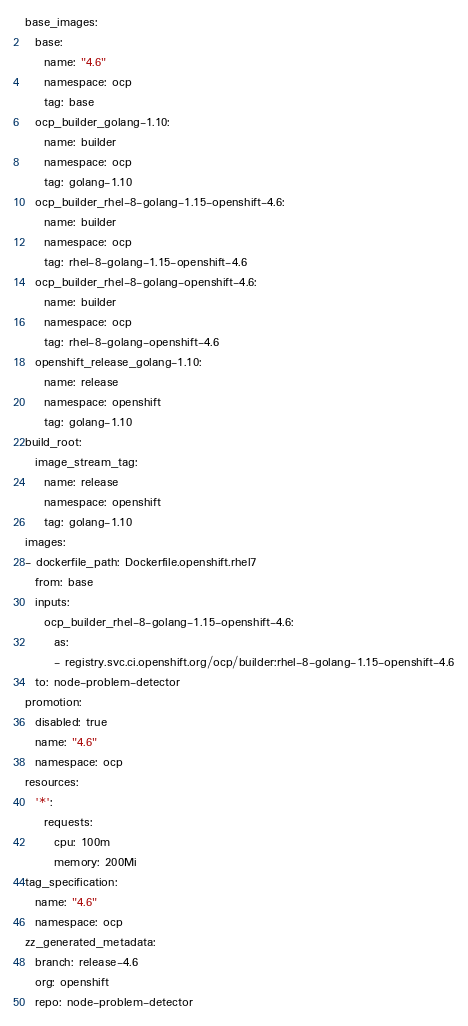<code> <loc_0><loc_0><loc_500><loc_500><_YAML_>base_images:
  base:
    name: "4.6"
    namespace: ocp
    tag: base
  ocp_builder_golang-1.10:
    name: builder
    namespace: ocp
    tag: golang-1.10
  ocp_builder_rhel-8-golang-1.15-openshift-4.6:
    name: builder
    namespace: ocp
    tag: rhel-8-golang-1.15-openshift-4.6
  ocp_builder_rhel-8-golang-openshift-4.6:
    name: builder
    namespace: ocp
    tag: rhel-8-golang-openshift-4.6
  openshift_release_golang-1.10:
    name: release
    namespace: openshift
    tag: golang-1.10
build_root:
  image_stream_tag:
    name: release
    namespace: openshift
    tag: golang-1.10
images:
- dockerfile_path: Dockerfile.openshift.rhel7
  from: base
  inputs:
    ocp_builder_rhel-8-golang-1.15-openshift-4.6:
      as:
      - registry.svc.ci.openshift.org/ocp/builder:rhel-8-golang-1.15-openshift-4.6
  to: node-problem-detector
promotion:
  disabled: true
  name: "4.6"
  namespace: ocp
resources:
  '*':
    requests:
      cpu: 100m
      memory: 200Mi
tag_specification:
  name: "4.6"
  namespace: ocp
zz_generated_metadata:
  branch: release-4.6
  org: openshift
  repo: node-problem-detector
</code> 